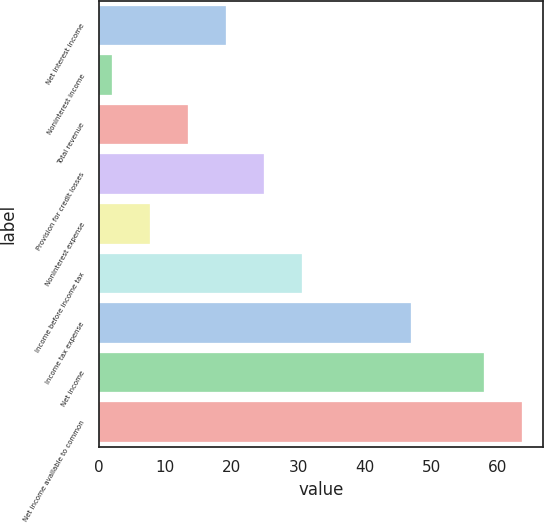Convert chart to OTSL. <chart><loc_0><loc_0><loc_500><loc_500><bar_chart><fcel>Net interest income<fcel>Noninterest income<fcel>Total revenue<fcel>Provision for credit losses<fcel>Noninterest expense<fcel>Income before income tax<fcel>Income tax expense<fcel>Net income<fcel>Net income available to common<nl><fcel>19.1<fcel>2<fcel>13.4<fcel>24.8<fcel>7.7<fcel>30.5<fcel>47<fcel>58<fcel>63.7<nl></chart> 